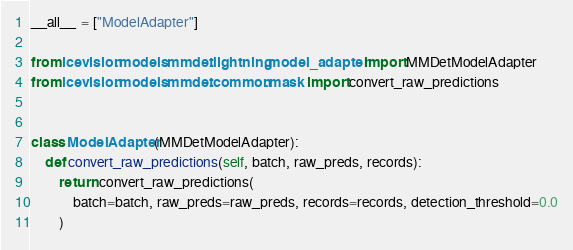<code> <loc_0><loc_0><loc_500><loc_500><_Python_>__all__ = ["ModelAdapter"]

from icevision.models.mmdet.lightning.model_adapter import MMDetModelAdapter
from icevision.models.mmdet.common.mask import convert_raw_predictions


class ModelAdapter(MMDetModelAdapter):
    def convert_raw_predictions(self, batch, raw_preds, records):
        return convert_raw_predictions(
            batch=batch, raw_preds=raw_preds, records=records, detection_threshold=0.0
        )
</code> 